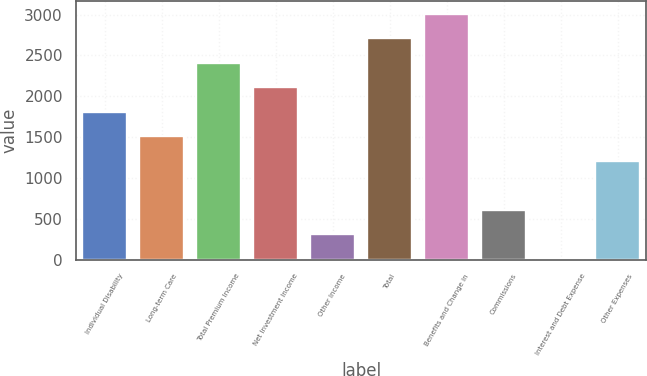<chart> <loc_0><loc_0><loc_500><loc_500><bar_chart><fcel>Individual Disability<fcel>Long-term Care<fcel>Total Premium Income<fcel>Net Investment Income<fcel>Other Income<fcel>Total<fcel>Benefits and Change in<fcel>Commissions<fcel>Interest and Debt Expense<fcel>Other Expenses<nl><fcel>1811.88<fcel>1511.65<fcel>2412.34<fcel>2112.11<fcel>310.73<fcel>2712.57<fcel>3012.8<fcel>610.96<fcel>10.5<fcel>1211.42<nl></chart> 